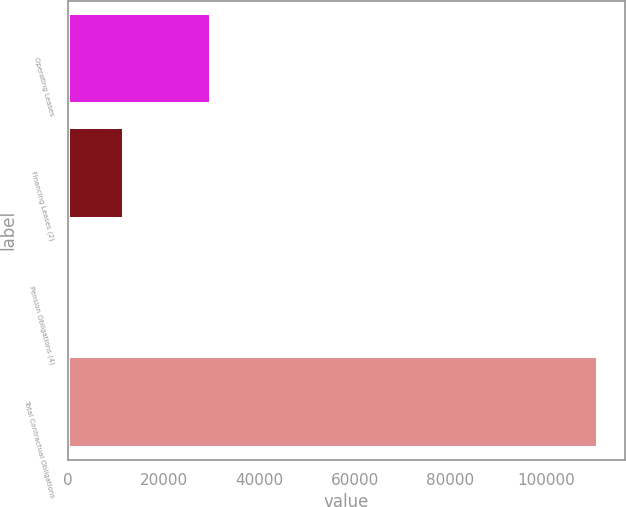<chart> <loc_0><loc_0><loc_500><loc_500><bar_chart><fcel>Operating Leases<fcel>Financing Leases (2)<fcel>Pension Obligations (4)<fcel>Total Contractual Obligations<nl><fcel>29829<fcel>11750.9<fcel>728<fcel>110957<nl></chart> 